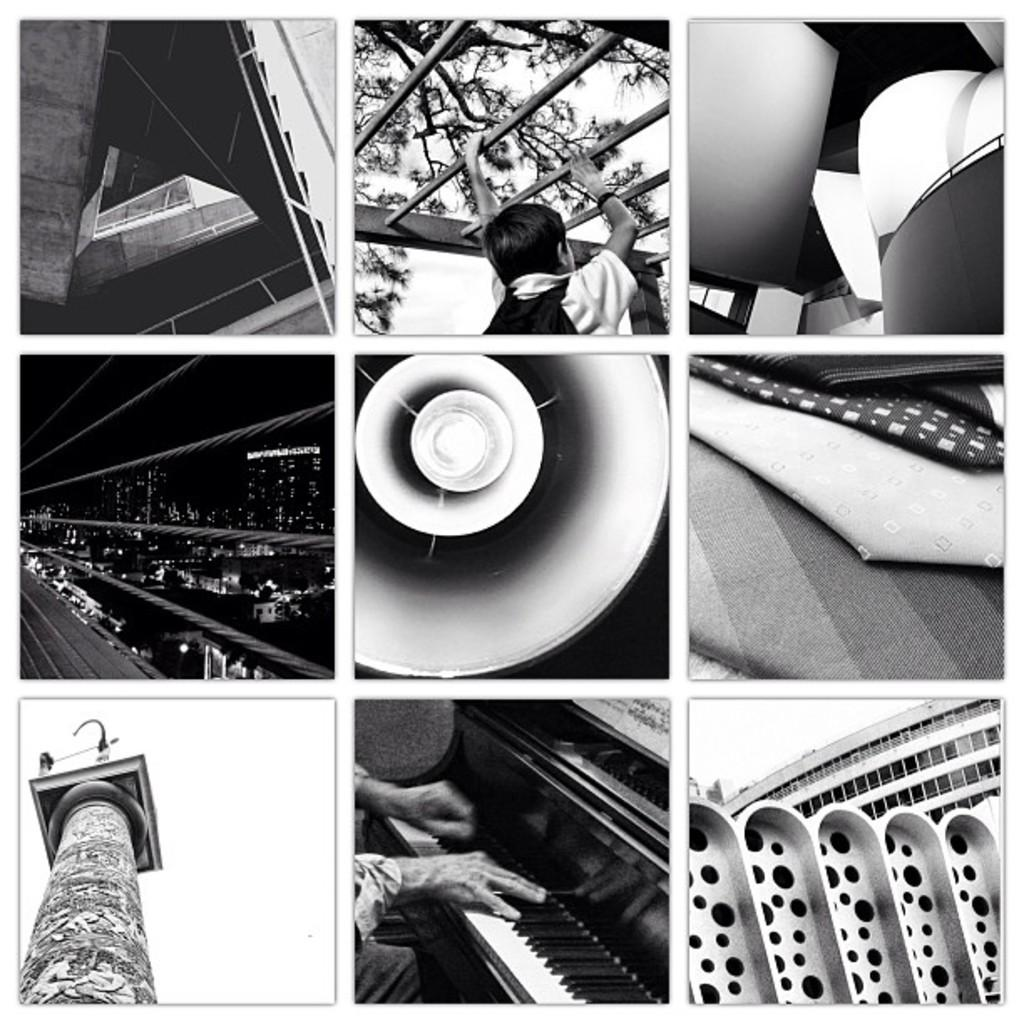What types of objects can be seen in the image? There are vehicles, buildings, trees, and a tower in the image. Can you describe any other objects in the image? Yes, there is a musical instrument and lights in the image. How many people are present in the image? There are two persons in the image. What type of copper material can be seen in the image? There is no copper material present in the image. What scientific experiment is being conducted in the image? There is no scientific experiment depicted in the image. 